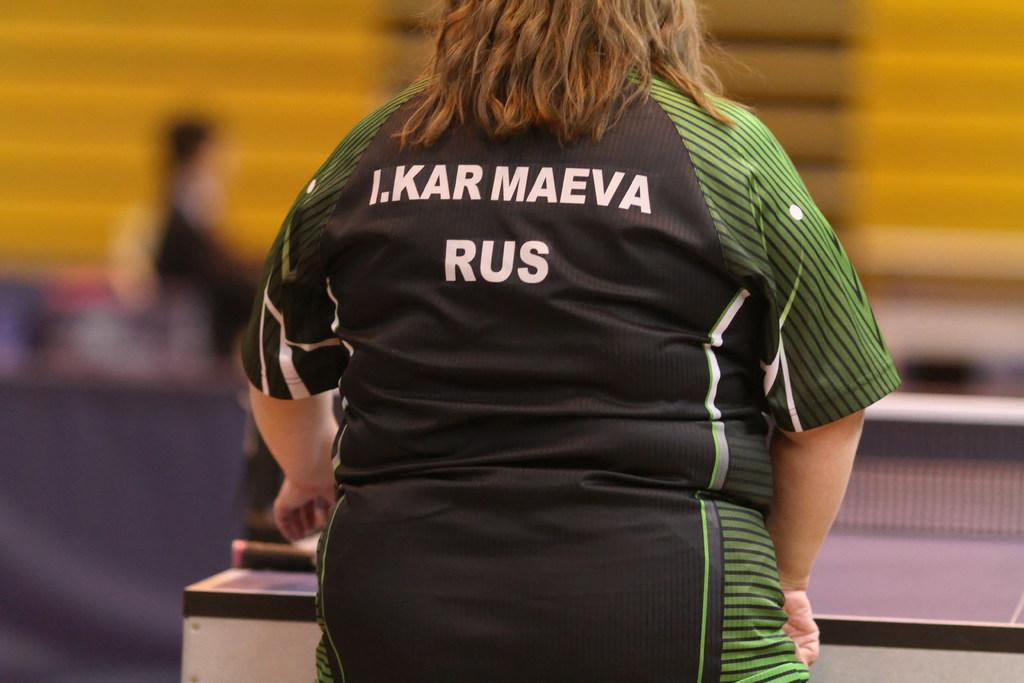<image>
Provide a brief description of the given image. A women IN a green and black jersey that says I.KARMAEVA RUS. on the back. 